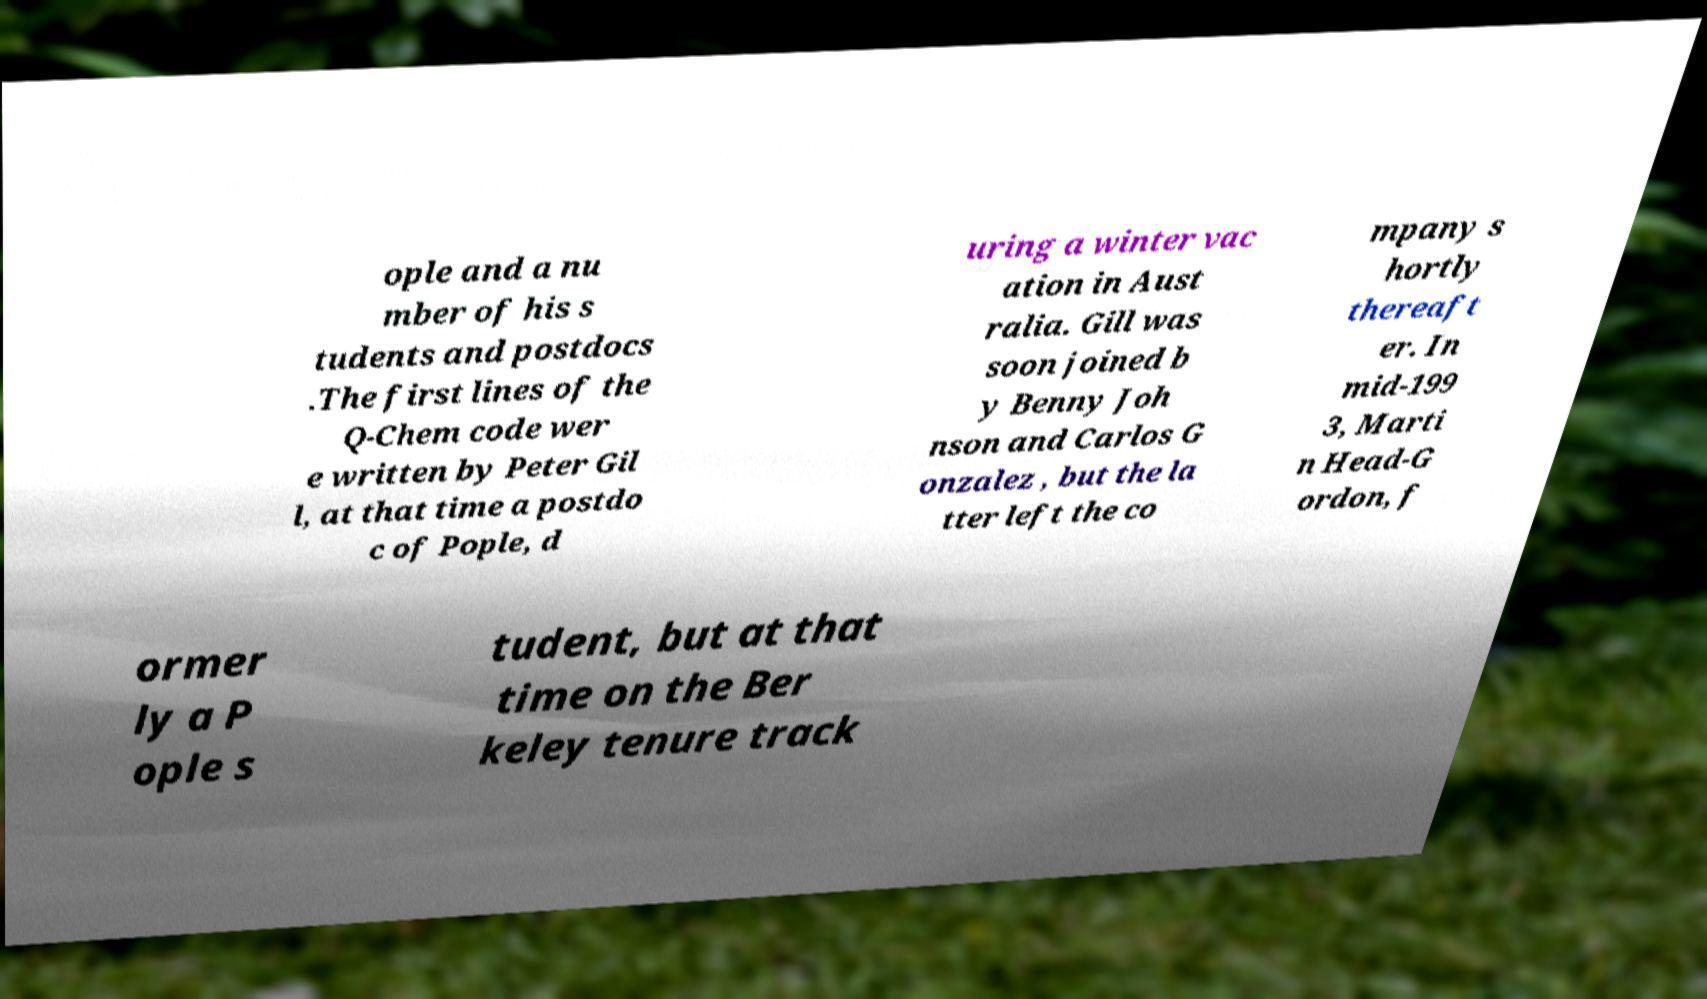For documentation purposes, I need the text within this image transcribed. Could you provide that? ople and a nu mber of his s tudents and postdocs .The first lines of the Q-Chem code wer e written by Peter Gil l, at that time a postdo c of Pople, d uring a winter vac ation in Aust ralia. Gill was soon joined b y Benny Joh nson and Carlos G onzalez , but the la tter left the co mpany s hortly thereaft er. In mid-199 3, Marti n Head-G ordon, f ormer ly a P ople s tudent, but at that time on the Ber keley tenure track 